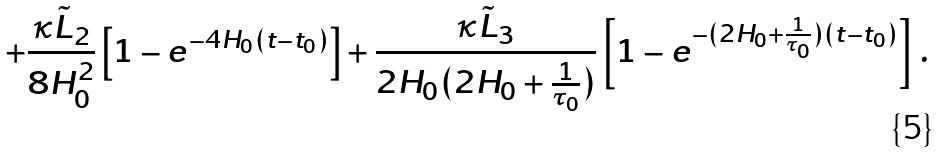Convert formula to latex. <formula><loc_0><loc_0><loc_500><loc_500>+ \frac { \kappa \tilde { L } _ { 2 } } { 8 H ^ { 2 } _ { 0 } } \left [ 1 - e ^ { - 4 H _ { 0 } ( t - t _ { 0 } ) } \right ] + \frac { \kappa \tilde { L } _ { 3 } } { 2 H _ { 0 } ( 2 H _ { 0 } + \frac { 1 } { \tau _ { 0 } } ) } \left [ 1 - e ^ { - ( 2 H _ { 0 } + \frac { 1 } { \tau _ { 0 } } ) ( t - t _ { 0 } ) } \right ] \, .</formula> 